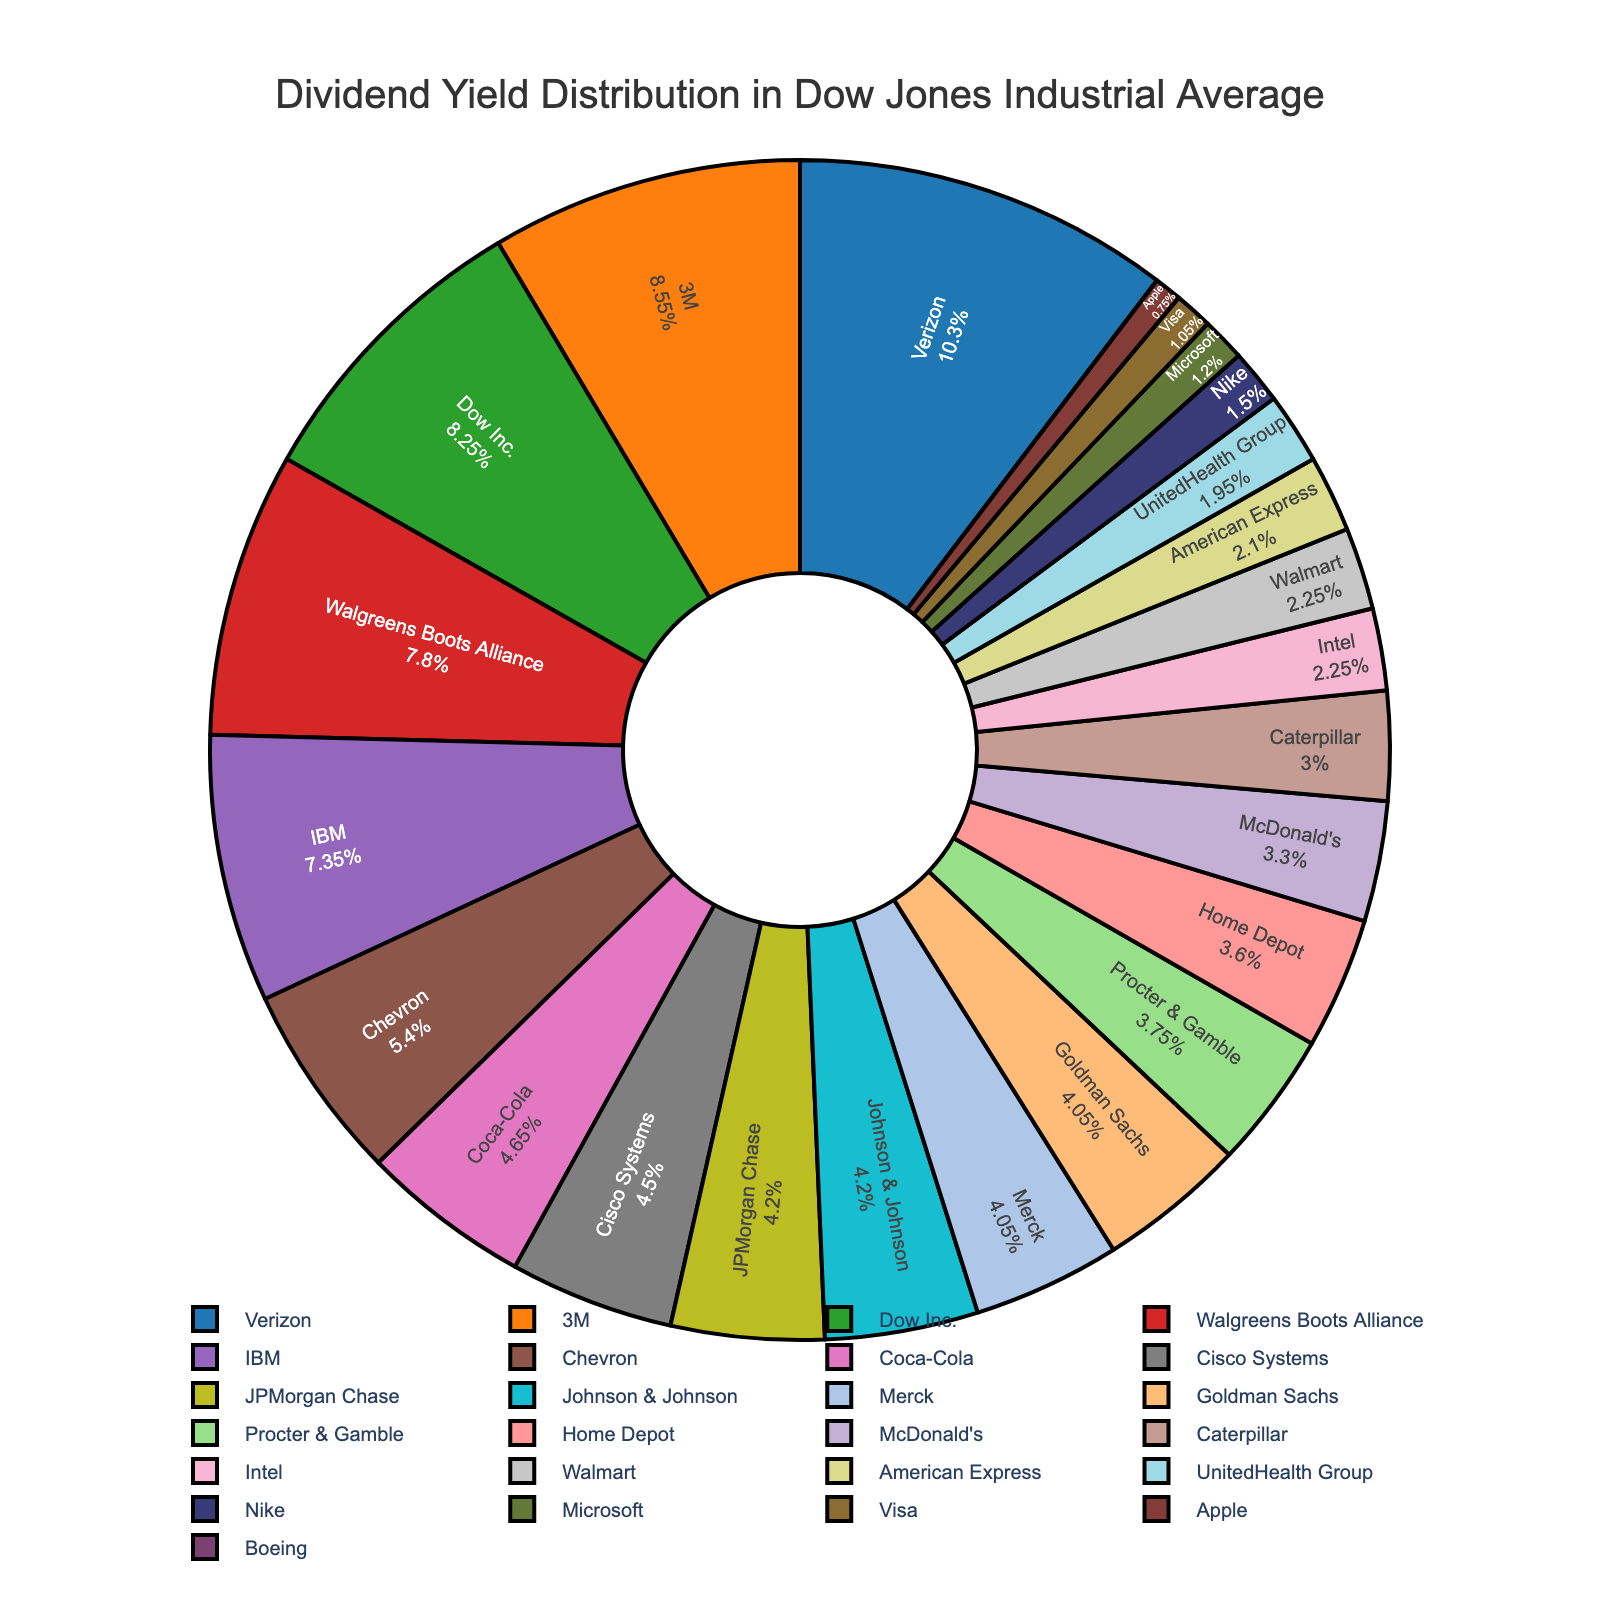What fraction of the total dividend yield is contributed by Intel and McDonald's together? To find the fraction contributed by Intel and McDonald's, sum their dividend yields: 1.5 (Intel) + 2.2 (McDonald's) = 3.7. Next, sum the yields of all companies: 2.8 + 3.1 + 2.5 + 5.7 + 6.9 + 3.6 + 4.9 + 5.2 + 5.5 + 2.0 + 2.7 + 1.5 + 3.0 + 2.8 + 0.0 + 0.5 + 0.8 + 1.5 + 2.4 + 2.7 + 0.7 + 1.3 + 2.2 + 1.0 + 1.4 = 66.7. The fraction is 3.7 / 66.7 ≈ 0.055
Answer: 0.055 Which company has the highest dividend yield, and what is it? Look for the largest slice in the pie chart. The largest slice corresponds to Verizon with a dividend yield of 6.9.
Answer: Verizon, 6.9 Compare the dividend yields of Caterpillar and Visa. Which company has a higher yield? Observe the sizes of the slices for Caterpillar and Visa. The dividend yield for Caterpillar is 2.0, and for Visa, it is 0.7. Hence, Caterpillar has a higher yield.
Answer: Caterpillar What is the total dividend yield of the three companies with the lowest yields? Identify the three smallest slices (Boeing [0.0], Apple [0.5], and Visa [0.7]). Sum their yields: 0.0 + 0.5 + 0.7 = 1.2.
Answer: 1.2 How does the dividend yield of JPMorgan Chase compare to that of Johnson & Johnson? Check the slices for JPMorgan Chase and Johnson & Johnson. Both have the same dividend yield of 2.8.
Answer: Equal What percentage of the total dividend yield is contributed by companies with yields greater than 5%? Identify the companies with yields greater than 5%: 3M (5.7), Verizon (6.9), Walgreens Boots Alliance (5.2), and Dow Inc. (5.5). Sum their yields: 5.7 + 6.9 + 5.2 + 5.5 = 23.3. Total yield is 66.7. The percentage is (23.3 / 66.7) * 100 ≈ 34.92%.
Answer: 34.92% Which two companies have yields closest to each other? Look for slices that are nearly the same size. Cisco Systems (3.0) and Coca-Cola (3.1) have very close yields.
Answer: Cisco Systems and Coca-Cola 